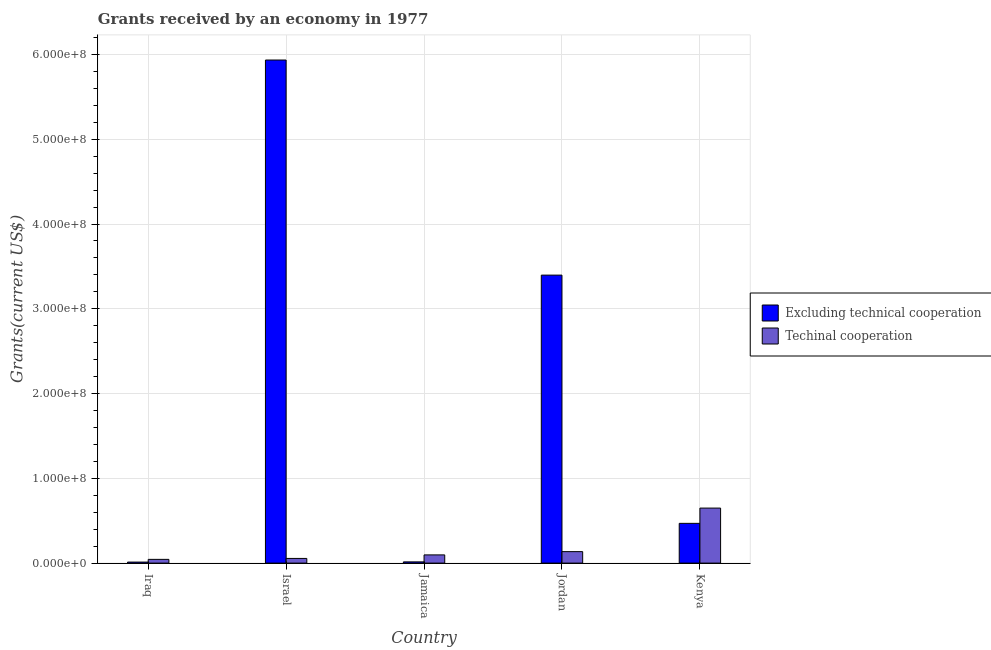How many groups of bars are there?
Offer a very short reply. 5. Are the number of bars per tick equal to the number of legend labels?
Keep it short and to the point. Yes. How many bars are there on the 2nd tick from the left?
Ensure brevity in your answer.  2. In how many cases, is the number of bars for a given country not equal to the number of legend labels?
Ensure brevity in your answer.  0. What is the amount of grants received(excluding technical cooperation) in Kenya?
Offer a terse response. 4.69e+07. Across all countries, what is the maximum amount of grants received(including technical cooperation)?
Offer a very short reply. 6.49e+07. Across all countries, what is the minimum amount of grants received(excluding technical cooperation)?
Give a very brief answer. 1.20e+06. In which country was the amount of grants received(including technical cooperation) minimum?
Your answer should be very brief. Iraq. What is the total amount of grants received(including technical cooperation) in the graph?
Your response must be concise. 9.80e+07. What is the difference between the amount of grants received(excluding technical cooperation) in Iraq and that in Jamaica?
Your answer should be very brief. -2.30e+05. What is the difference between the amount of grants received(excluding technical cooperation) in Israel and the amount of grants received(including technical cooperation) in Iraq?
Your answer should be compact. 5.89e+08. What is the average amount of grants received(including technical cooperation) per country?
Offer a very short reply. 1.96e+07. What is the difference between the amount of grants received(including technical cooperation) and amount of grants received(excluding technical cooperation) in Iraq?
Provide a short and direct response. 3.20e+06. In how many countries, is the amount of grants received(excluding technical cooperation) greater than 400000000 US$?
Your answer should be very brief. 1. What is the ratio of the amount of grants received(excluding technical cooperation) in Jamaica to that in Jordan?
Offer a terse response. 0. Is the amount of grants received(including technical cooperation) in Israel less than that in Jamaica?
Keep it short and to the point. Yes. Is the difference between the amount of grants received(excluding technical cooperation) in Jamaica and Kenya greater than the difference between the amount of grants received(including technical cooperation) in Jamaica and Kenya?
Your answer should be very brief. Yes. What is the difference between the highest and the second highest amount of grants received(including technical cooperation)?
Provide a short and direct response. 5.14e+07. What is the difference between the highest and the lowest amount of grants received(excluding technical cooperation)?
Ensure brevity in your answer.  5.92e+08. What does the 1st bar from the left in Israel represents?
Give a very brief answer. Excluding technical cooperation. What does the 1st bar from the right in Jordan represents?
Provide a succinct answer. Techinal cooperation. What is the difference between two consecutive major ticks on the Y-axis?
Provide a short and direct response. 1.00e+08. Are the values on the major ticks of Y-axis written in scientific E-notation?
Offer a terse response. Yes. Does the graph contain any zero values?
Offer a very short reply. No. Does the graph contain grids?
Offer a very short reply. Yes. How are the legend labels stacked?
Offer a terse response. Vertical. What is the title of the graph?
Ensure brevity in your answer.  Grants received by an economy in 1977. Does "International Visitors" appear as one of the legend labels in the graph?
Provide a succinct answer. No. What is the label or title of the X-axis?
Your response must be concise. Country. What is the label or title of the Y-axis?
Your answer should be compact. Grants(current US$). What is the Grants(current US$) of Excluding technical cooperation in Iraq?
Your answer should be compact. 1.20e+06. What is the Grants(current US$) of Techinal cooperation in Iraq?
Your answer should be very brief. 4.40e+06. What is the Grants(current US$) of Excluding technical cooperation in Israel?
Keep it short and to the point. 5.93e+08. What is the Grants(current US$) of Techinal cooperation in Israel?
Give a very brief answer. 5.51e+06. What is the Grants(current US$) of Excluding technical cooperation in Jamaica?
Your answer should be very brief. 1.43e+06. What is the Grants(current US$) of Techinal cooperation in Jamaica?
Keep it short and to the point. 9.67e+06. What is the Grants(current US$) of Excluding technical cooperation in Jordan?
Offer a very short reply. 3.40e+08. What is the Grants(current US$) of Techinal cooperation in Jordan?
Offer a very short reply. 1.35e+07. What is the Grants(current US$) of Excluding technical cooperation in Kenya?
Provide a short and direct response. 4.69e+07. What is the Grants(current US$) of Techinal cooperation in Kenya?
Your answer should be very brief. 6.49e+07. Across all countries, what is the maximum Grants(current US$) of Excluding technical cooperation?
Provide a short and direct response. 5.93e+08. Across all countries, what is the maximum Grants(current US$) of Techinal cooperation?
Keep it short and to the point. 6.49e+07. Across all countries, what is the minimum Grants(current US$) of Excluding technical cooperation?
Your response must be concise. 1.20e+06. Across all countries, what is the minimum Grants(current US$) of Techinal cooperation?
Ensure brevity in your answer.  4.40e+06. What is the total Grants(current US$) in Excluding technical cooperation in the graph?
Make the answer very short. 9.83e+08. What is the total Grants(current US$) in Techinal cooperation in the graph?
Your response must be concise. 9.80e+07. What is the difference between the Grants(current US$) in Excluding technical cooperation in Iraq and that in Israel?
Provide a succinct answer. -5.92e+08. What is the difference between the Grants(current US$) in Techinal cooperation in Iraq and that in Israel?
Your answer should be compact. -1.11e+06. What is the difference between the Grants(current US$) of Techinal cooperation in Iraq and that in Jamaica?
Keep it short and to the point. -5.27e+06. What is the difference between the Grants(current US$) of Excluding technical cooperation in Iraq and that in Jordan?
Offer a very short reply. -3.39e+08. What is the difference between the Grants(current US$) of Techinal cooperation in Iraq and that in Jordan?
Make the answer very short. -9.13e+06. What is the difference between the Grants(current US$) of Excluding technical cooperation in Iraq and that in Kenya?
Your answer should be compact. -4.57e+07. What is the difference between the Grants(current US$) in Techinal cooperation in Iraq and that in Kenya?
Your answer should be very brief. -6.05e+07. What is the difference between the Grants(current US$) of Excluding technical cooperation in Israel and that in Jamaica?
Your response must be concise. 5.92e+08. What is the difference between the Grants(current US$) of Techinal cooperation in Israel and that in Jamaica?
Keep it short and to the point. -4.16e+06. What is the difference between the Grants(current US$) of Excluding technical cooperation in Israel and that in Jordan?
Give a very brief answer. 2.54e+08. What is the difference between the Grants(current US$) of Techinal cooperation in Israel and that in Jordan?
Your response must be concise. -8.02e+06. What is the difference between the Grants(current US$) in Excluding technical cooperation in Israel and that in Kenya?
Your answer should be compact. 5.47e+08. What is the difference between the Grants(current US$) in Techinal cooperation in Israel and that in Kenya?
Your answer should be compact. -5.94e+07. What is the difference between the Grants(current US$) in Excluding technical cooperation in Jamaica and that in Jordan?
Offer a terse response. -3.38e+08. What is the difference between the Grants(current US$) of Techinal cooperation in Jamaica and that in Jordan?
Provide a succinct answer. -3.86e+06. What is the difference between the Grants(current US$) of Excluding technical cooperation in Jamaica and that in Kenya?
Provide a succinct answer. -4.54e+07. What is the difference between the Grants(current US$) of Techinal cooperation in Jamaica and that in Kenya?
Your answer should be compact. -5.52e+07. What is the difference between the Grants(current US$) in Excluding technical cooperation in Jordan and that in Kenya?
Ensure brevity in your answer.  2.93e+08. What is the difference between the Grants(current US$) of Techinal cooperation in Jordan and that in Kenya?
Your answer should be compact. -5.14e+07. What is the difference between the Grants(current US$) of Excluding technical cooperation in Iraq and the Grants(current US$) of Techinal cooperation in Israel?
Make the answer very short. -4.31e+06. What is the difference between the Grants(current US$) in Excluding technical cooperation in Iraq and the Grants(current US$) in Techinal cooperation in Jamaica?
Offer a terse response. -8.47e+06. What is the difference between the Grants(current US$) in Excluding technical cooperation in Iraq and the Grants(current US$) in Techinal cooperation in Jordan?
Offer a terse response. -1.23e+07. What is the difference between the Grants(current US$) in Excluding technical cooperation in Iraq and the Grants(current US$) in Techinal cooperation in Kenya?
Offer a terse response. -6.37e+07. What is the difference between the Grants(current US$) in Excluding technical cooperation in Israel and the Grants(current US$) in Techinal cooperation in Jamaica?
Offer a very short reply. 5.84e+08. What is the difference between the Grants(current US$) of Excluding technical cooperation in Israel and the Grants(current US$) of Techinal cooperation in Jordan?
Offer a very short reply. 5.80e+08. What is the difference between the Grants(current US$) in Excluding technical cooperation in Israel and the Grants(current US$) in Techinal cooperation in Kenya?
Make the answer very short. 5.29e+08. What is the difference between the Grants(current US$) in Excluding technical cooperation in Jamaica and the Grants(current US$) in Techinal cooperation in Jordan?
Make the answer very short. -1.21e+07. What is the difference between the Grants(current US$) in Excluding technical cooperation in Jamaica and the Grants(current US$) in Techinal cooperation in Kenya?
Your answer should be very brief. -6.35e+07. What is the difference between the Grants(current US$) in Excluding technical cooperation in Jordan and the Grants(current US$) in Techinal cooperation in Kenya?
Provide a succinct answer. 2.75e+08. What is the average Grants(current US$) in Excluding technical cooperation per country?
Your answer should be compact. 1.97e+08. What is the average Grants(current US$) in Techinal cooperation per country?
Make the answer very short. 1.96e+07. What is the difference between the Grants(current US$) of Excluding technical cooperation and Grants(current US$) of Techinal cooperation in Iraq?
Provide a short and direct response. -3.20e+06. What is the difference between the Grants(current US$) in Excluding technical cooperation and Grants(current US$) in Techinal cooperation in Israel?
Your answer should be very brief. 5.88e+08. What is the difference between the Grants(current US$) in Excluding technical cooperation and Grants(current US$) in Techinal cooperation in Jamaica?
Provide a succinct answer. -8.24e+06. What is the difference between the Grants(current US$) in Excluding technical cooperation and Grants(current US$) in Techinal cooperation in Jordan?
Give a very brief answer. 3.26e+08. What is the difference between the Grants(current US$) of Excluding technical cooperation and Grants(current US$) of Techinal cooperation in Kenya?
Ensure brevity in your answer.  -1.80e+07. What is the ratio of the Grants(current US$) of Excluding technical cooperation in Iraq to that in Israel?
Your answer should be compact. 0. What is the ratio of the Grants(current US$) in Techinal cooperation in Iraq to that in Israel?
Offer a very short reply. 0.8. What is the ratio of the Grants(current US$) of Excluding technical cooperation in Iraq to that in Jamaica?
Offer a very short reply. 0.84. What is the ratio of the Grants(current US$) of Techinal cooperation in Iraq to that in Jamaica?
Your answer should be compact. 0.46. What is the ratio of the Grants(current US$) in Excluding technical cooperation in Iraq to that in Jordan?
Your answer should be compact. 0. What is the ratio of the Grants(current US$) of Techinal cooperation in Iraq to that in Jordan?
Your response must be concise. 0.33. What is the ratio of the Grants(current US$) of Excluding technical cooperation in Iraq to that in Kenya?
Offer a terse response. 0.03. What is the ratio of the Grants(current US$) of Techinal cooperation in Iraq to that in Kenya?
Ensure brevity in your answer.  0.07. What is the ratio of the Grants(current US$) of Excluding technical cooperation in Israel to that in Jamaica?
Ensure brevity in your answer.  415.01. What is the ratio of the Grants(current US$) of Techinal cooperation in Israel to that in Jamaica?
Your response must be concise. 0.57. What is the ratio of the Grants(current US$) in Excluding technical cooperation in Israel to that in Jordan?
Your answer should be compact. 1.75. What is the ratio of the Grants(current US$) of Techinal cooperation in Israel to that in Jordan?
Make the answer very short. 0.41. What is the ratio of the Grants(current US$) in Excluding technical cooperation in Israel to that in Kenya?
Provide a short and direct response. 12.66. What is the ratio of the Grants(current US$) of Techinal cooperation in Israel to that in Kenya?
Ensure brevity in your answer.  0.08. What is the ratio of the Grants(current US$) of Excluding technical cooperation in Jamaica to that in Jordan?
Your response must be concise. 0. What is the ratio of the Grants(current US$) of Techinal cooperation in Jamaica to that in Jordan?
Give a very brief answer. 0.71. What is the ratio of the Grants(current US$) of Excluding technical cooperation in Jamaica to that in Kenya?
Provide a succinct answer. 0.03. What is the ratio of the Grants(current US$) in Techinal cooperation in Jamaica to that in Kenya?
Make the answer very short. 0.15. What is the ratio of the Grants(current US$) in Excluding technical cooperation in Jordan to that in Kenya?
Your answer should be compact. 7.25. What is the ratio of the Grants(current US$) in Techinal cooperation in Jordan to that in Kenya?
Your response must be concise. 0.21. What is the difference between the highest and the second highest Grants(current US$) of Excluding technical cooperation?
Make the answer very short. 2.54e+08. What is the difference between the highest and the second highest Grants(current US$) in Techinal cooperation?
Provide a succinct answer. 5.14e+07. What is the difference between the highest and the lowest Grants(current US$) of Excluding technical cooperation?
Ensure brevity in your answer.  5.92e+08. What is the difference between the highest and the lowest Grants(current US$) of Techinal cooperation?
Your answer should be very brief. 6.05e+07. 